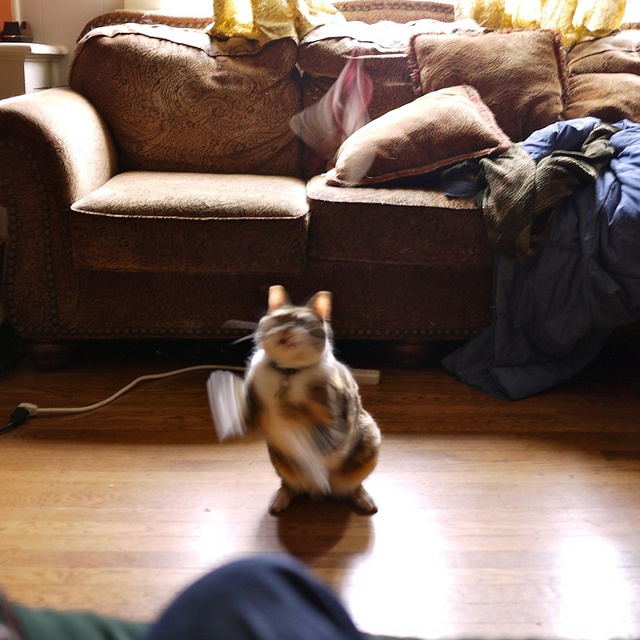Describe the objects in this image and their specific colors. I can see couch in brown, black, maroon, white, and gray tones, cat in brown, maroon, gray, and black tones, and people in brown, gray, black, and darkblue tones in this image. 